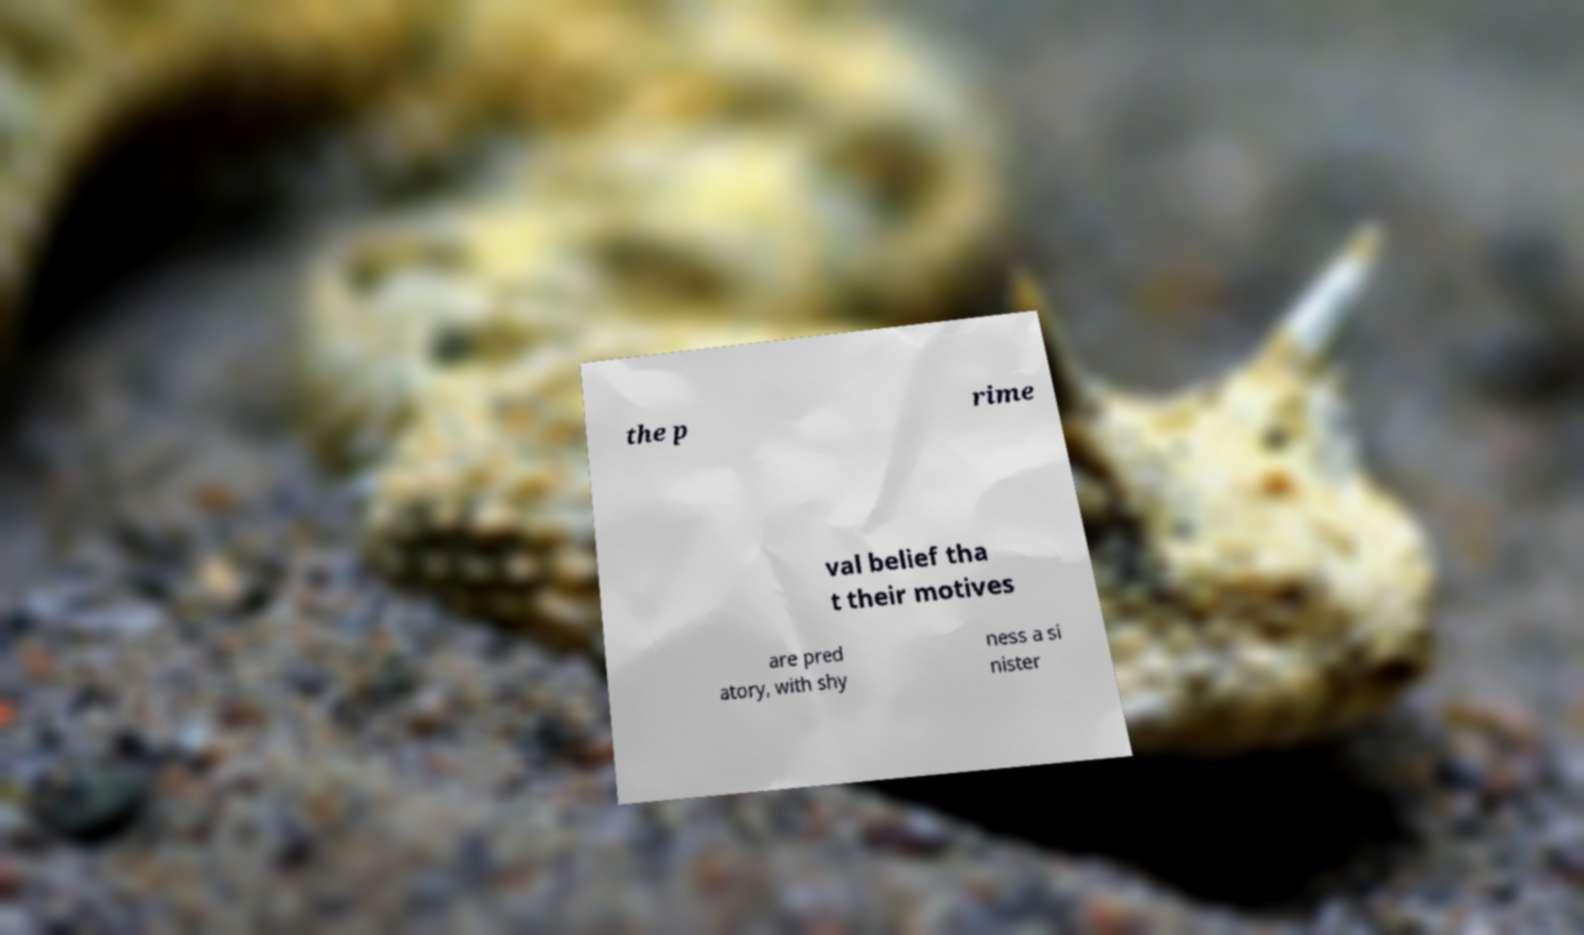For documentation purposes, I need the text within this image transcribed. Could you provide that? the p rime val belief tha t their motives are pred atory, with shy ness a si nister 